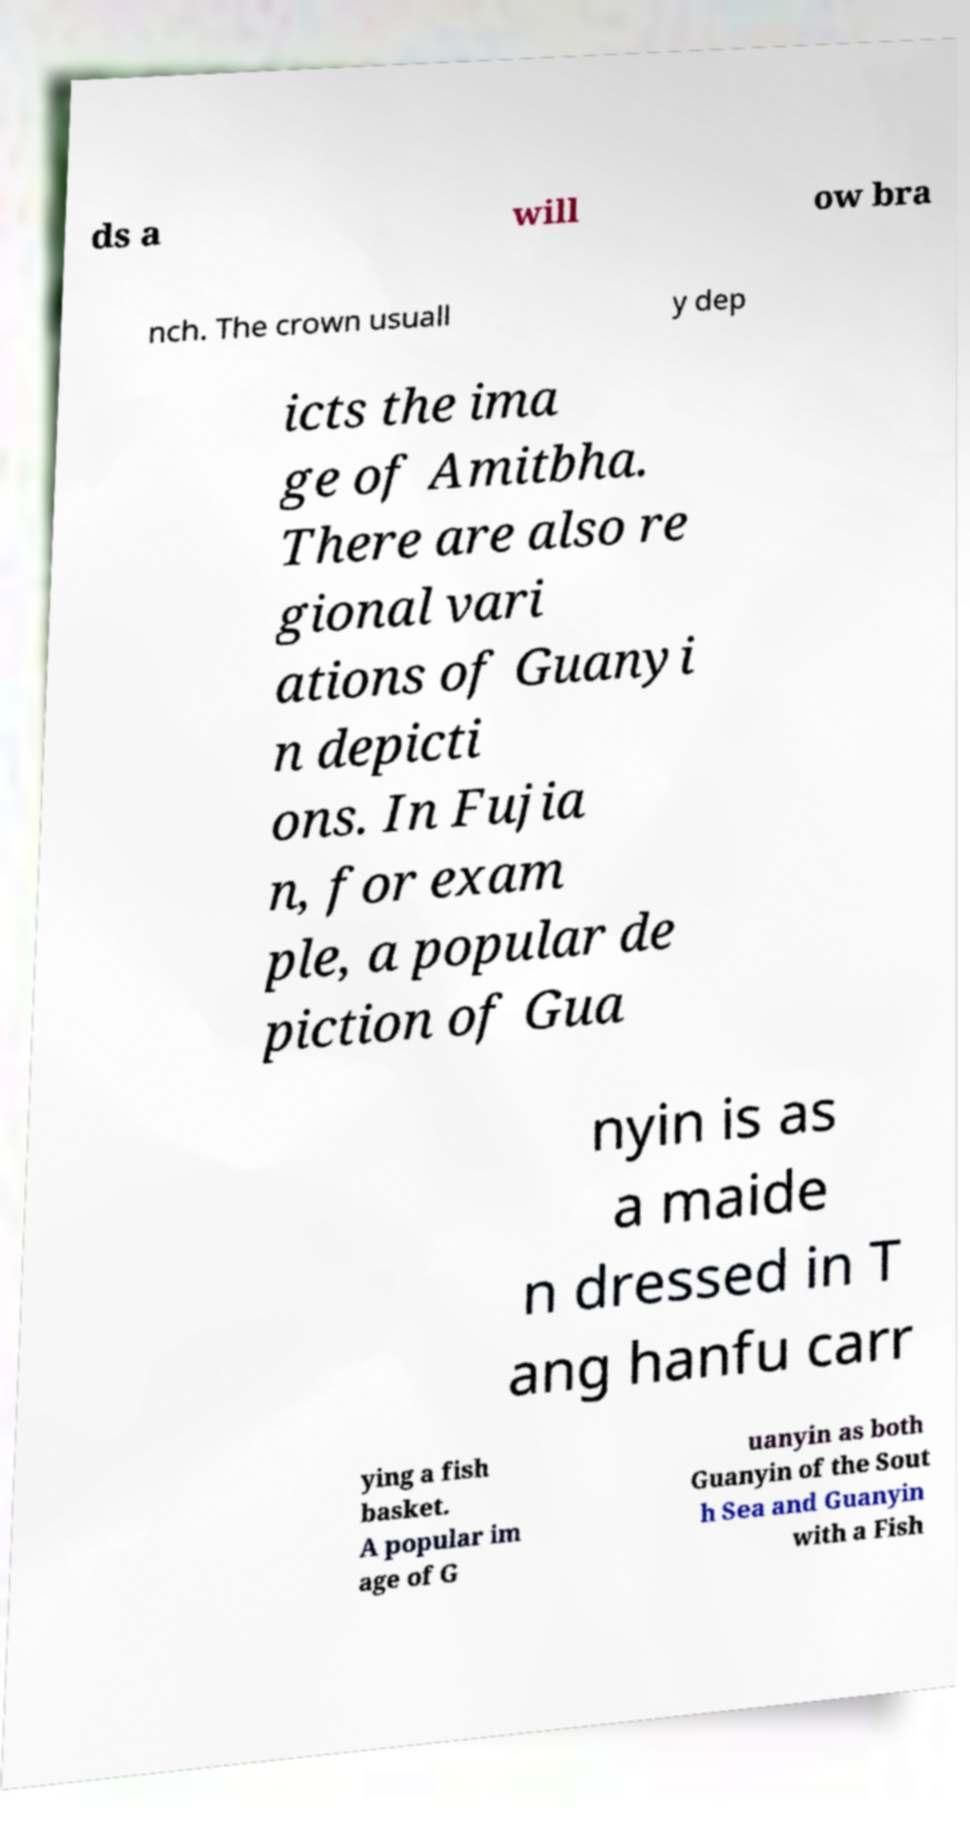Please read and relay the text visible in this image. What does it say? ds a will ow bra nch. The crown usuall y dep icts the ima ge of Amitbha. There are also re gional vari ations of Guanyi n depicti ons. In Fujia n, for exam ple, a popular de piction of Gua nyin is as a maide n dressed in T ang hanfu carr ying a fish basket. A popular im age of G uanyin as both Guanyin of the Sout h Sea and Guanyin with a Fish 